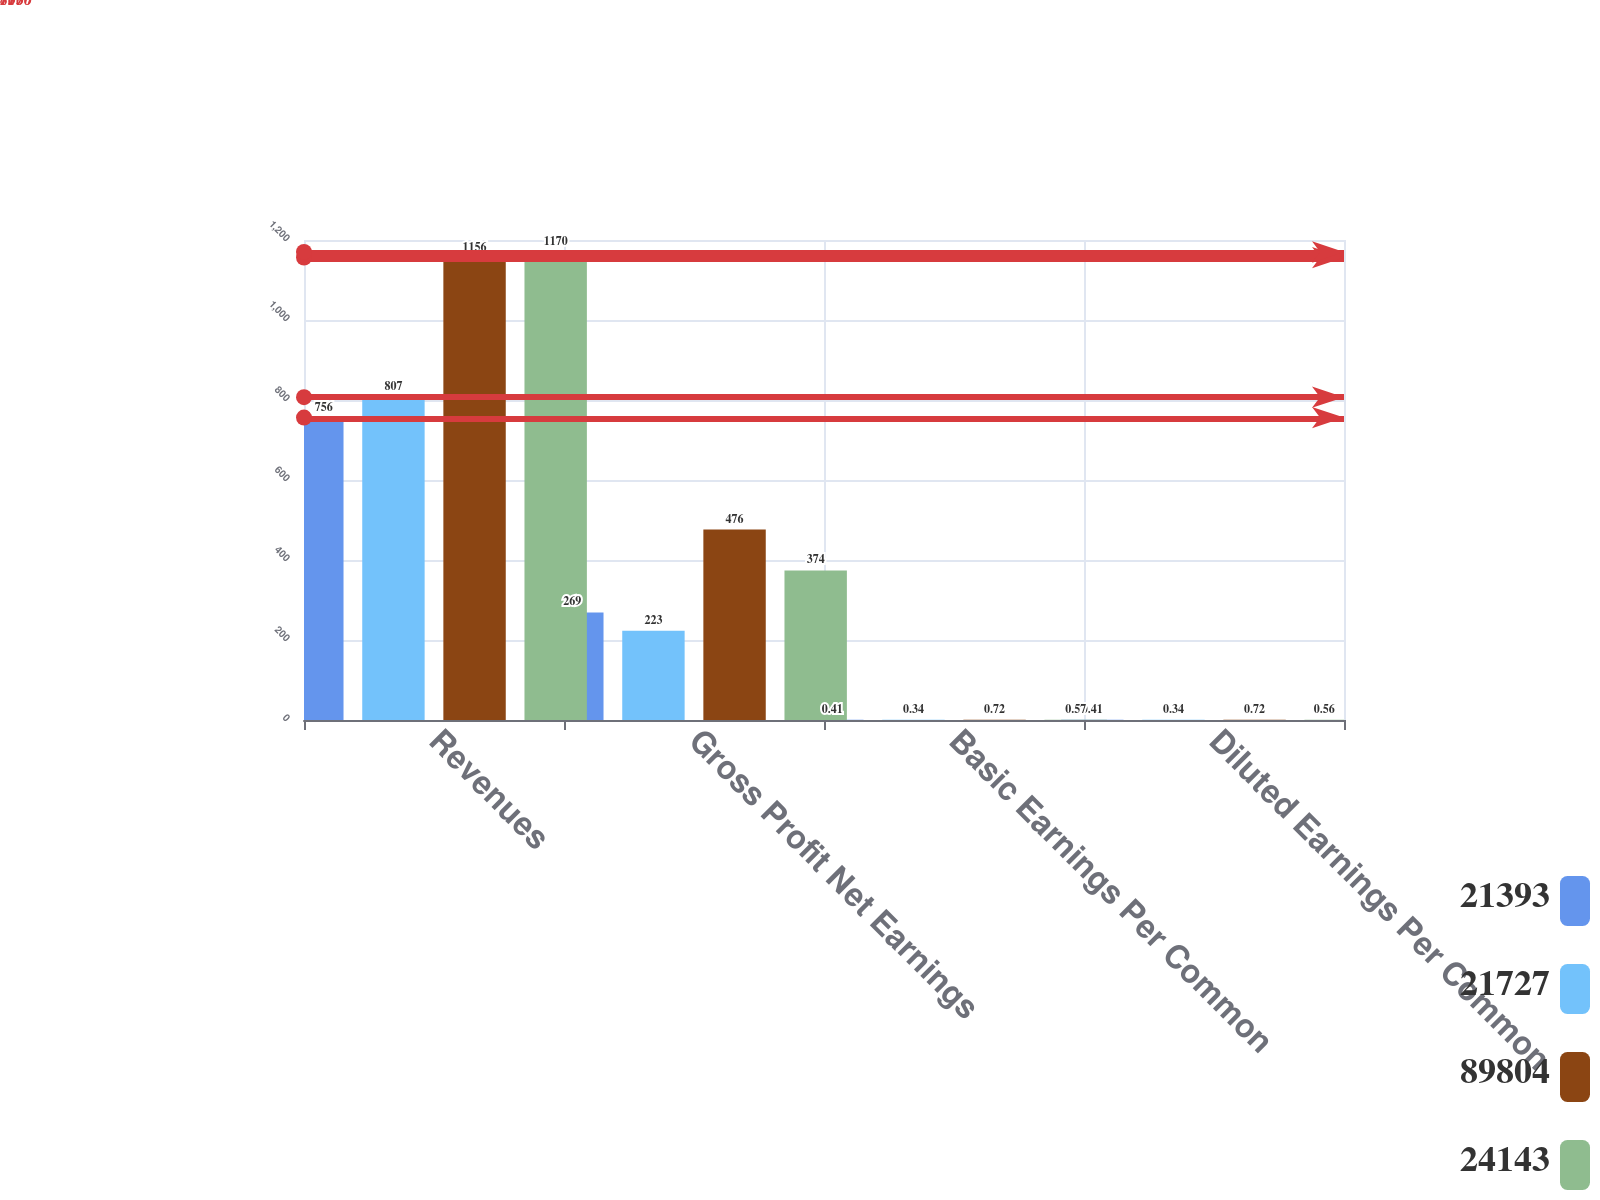Convert chart to OTSL. <chart><loc_0><loc_0><loc_500><loc_500><stacked_bar_chart><ecel><fcel>Revenues<fcel>Gross Profit Net Earnings<fcel>Basic Earnings Per Common<fcel>Diluted Earnings Per Common<nl><fcel>21393<fcel>756<fcel>269<fcel>0.41<fcel>0.41<nl><fcel>21727<fcel>807<fcel>223<fcel>0.34<fcel>0.34<nl><fcel>89804<fcel>1156<fcel>476<fcel>0.72<fcel>0.72<nl><fcel>24143<fcel>1170<fcel>374<fcel>0.57<fcel>0.56<nl></chart> 